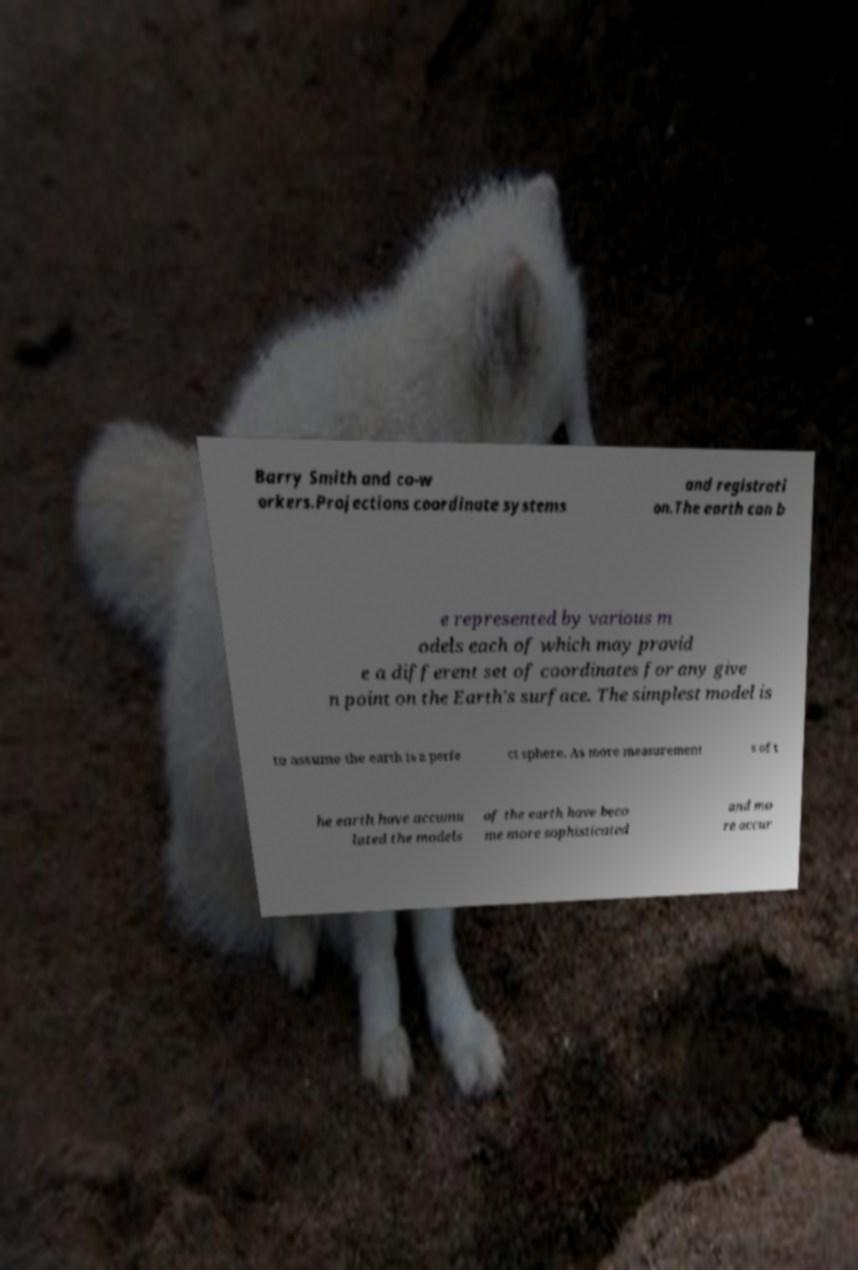Could you assist in decoding the text presented in this image and type it out clearly? Barry Smith and co-w orkers.Projections coordinate systems and registrati on.The earth can b e represented by various m odels each of which may provid e a different set of coordinates for any give n point on the Earth's surface. The simplest model is to assume the earth is a perfe ct sphere. As more measurement s of t he earth have accumu lated the models of the earth have beco me more sophisticated and mo re accur 